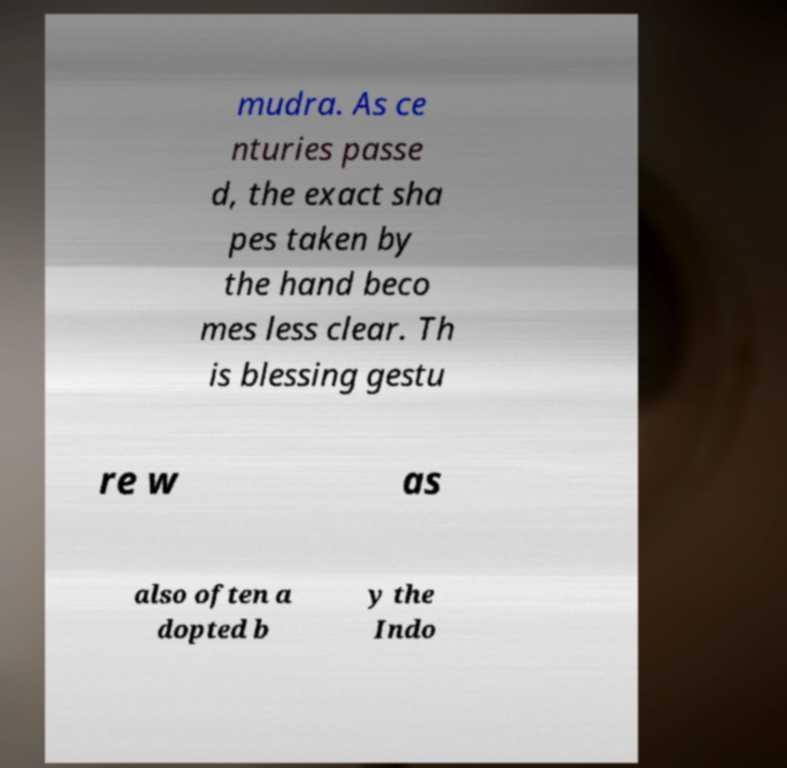Can you read and provide the text displayed in the image?This photo seems to have some interesting text. Can you extract and type it out for me? mudra. As ce nturies passe d, the exact sha pes taken by the hand beco mes less clear. Th is blessing gestu re w as also often a dopted b y the Indo 